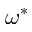Convert formula to latex. <formula><loc_0><loc_0><loc_500><loc_500>\omega ^ { \ast }</formula> 